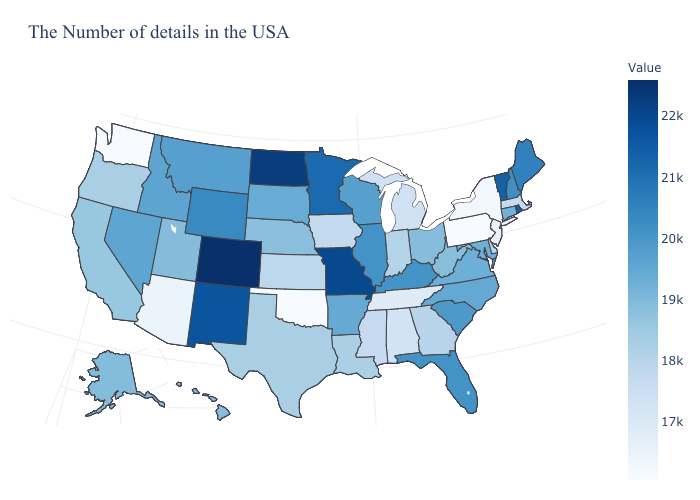Does the map have missing data?
Write a very short answer. No. Which states have the lowest value in the Northeast?
Write a very short answer. Pennsylvania. 